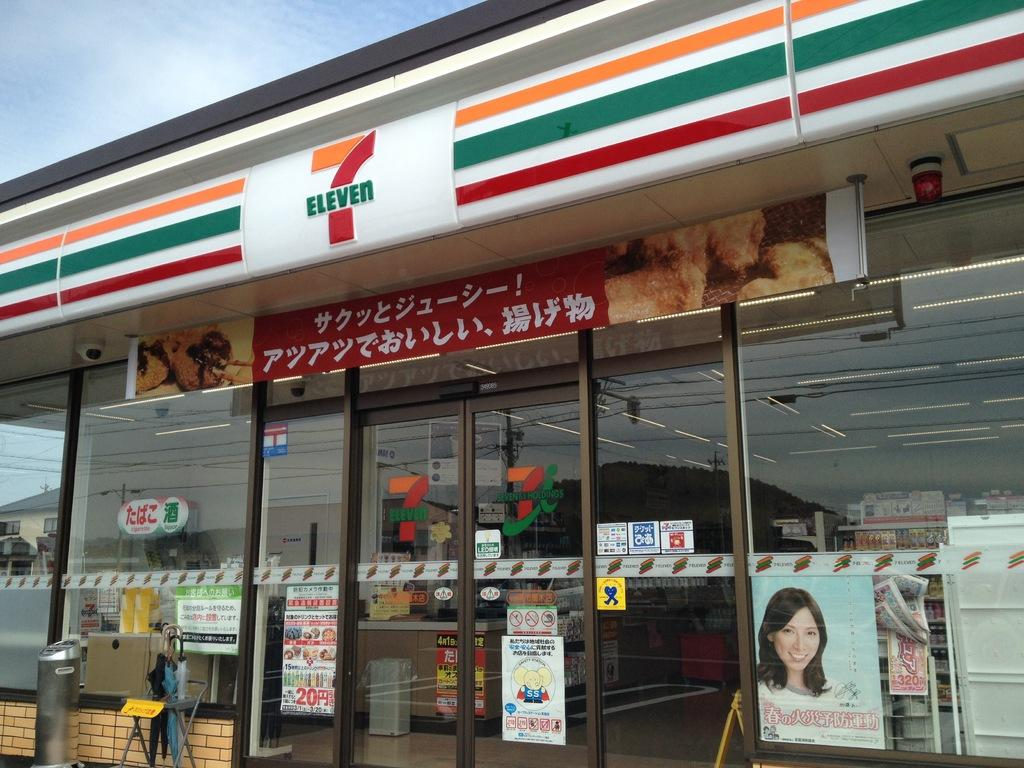<image>
Share a concise interpretation of the image provided. a 7 Eleven store exterior with signs in Japanese 